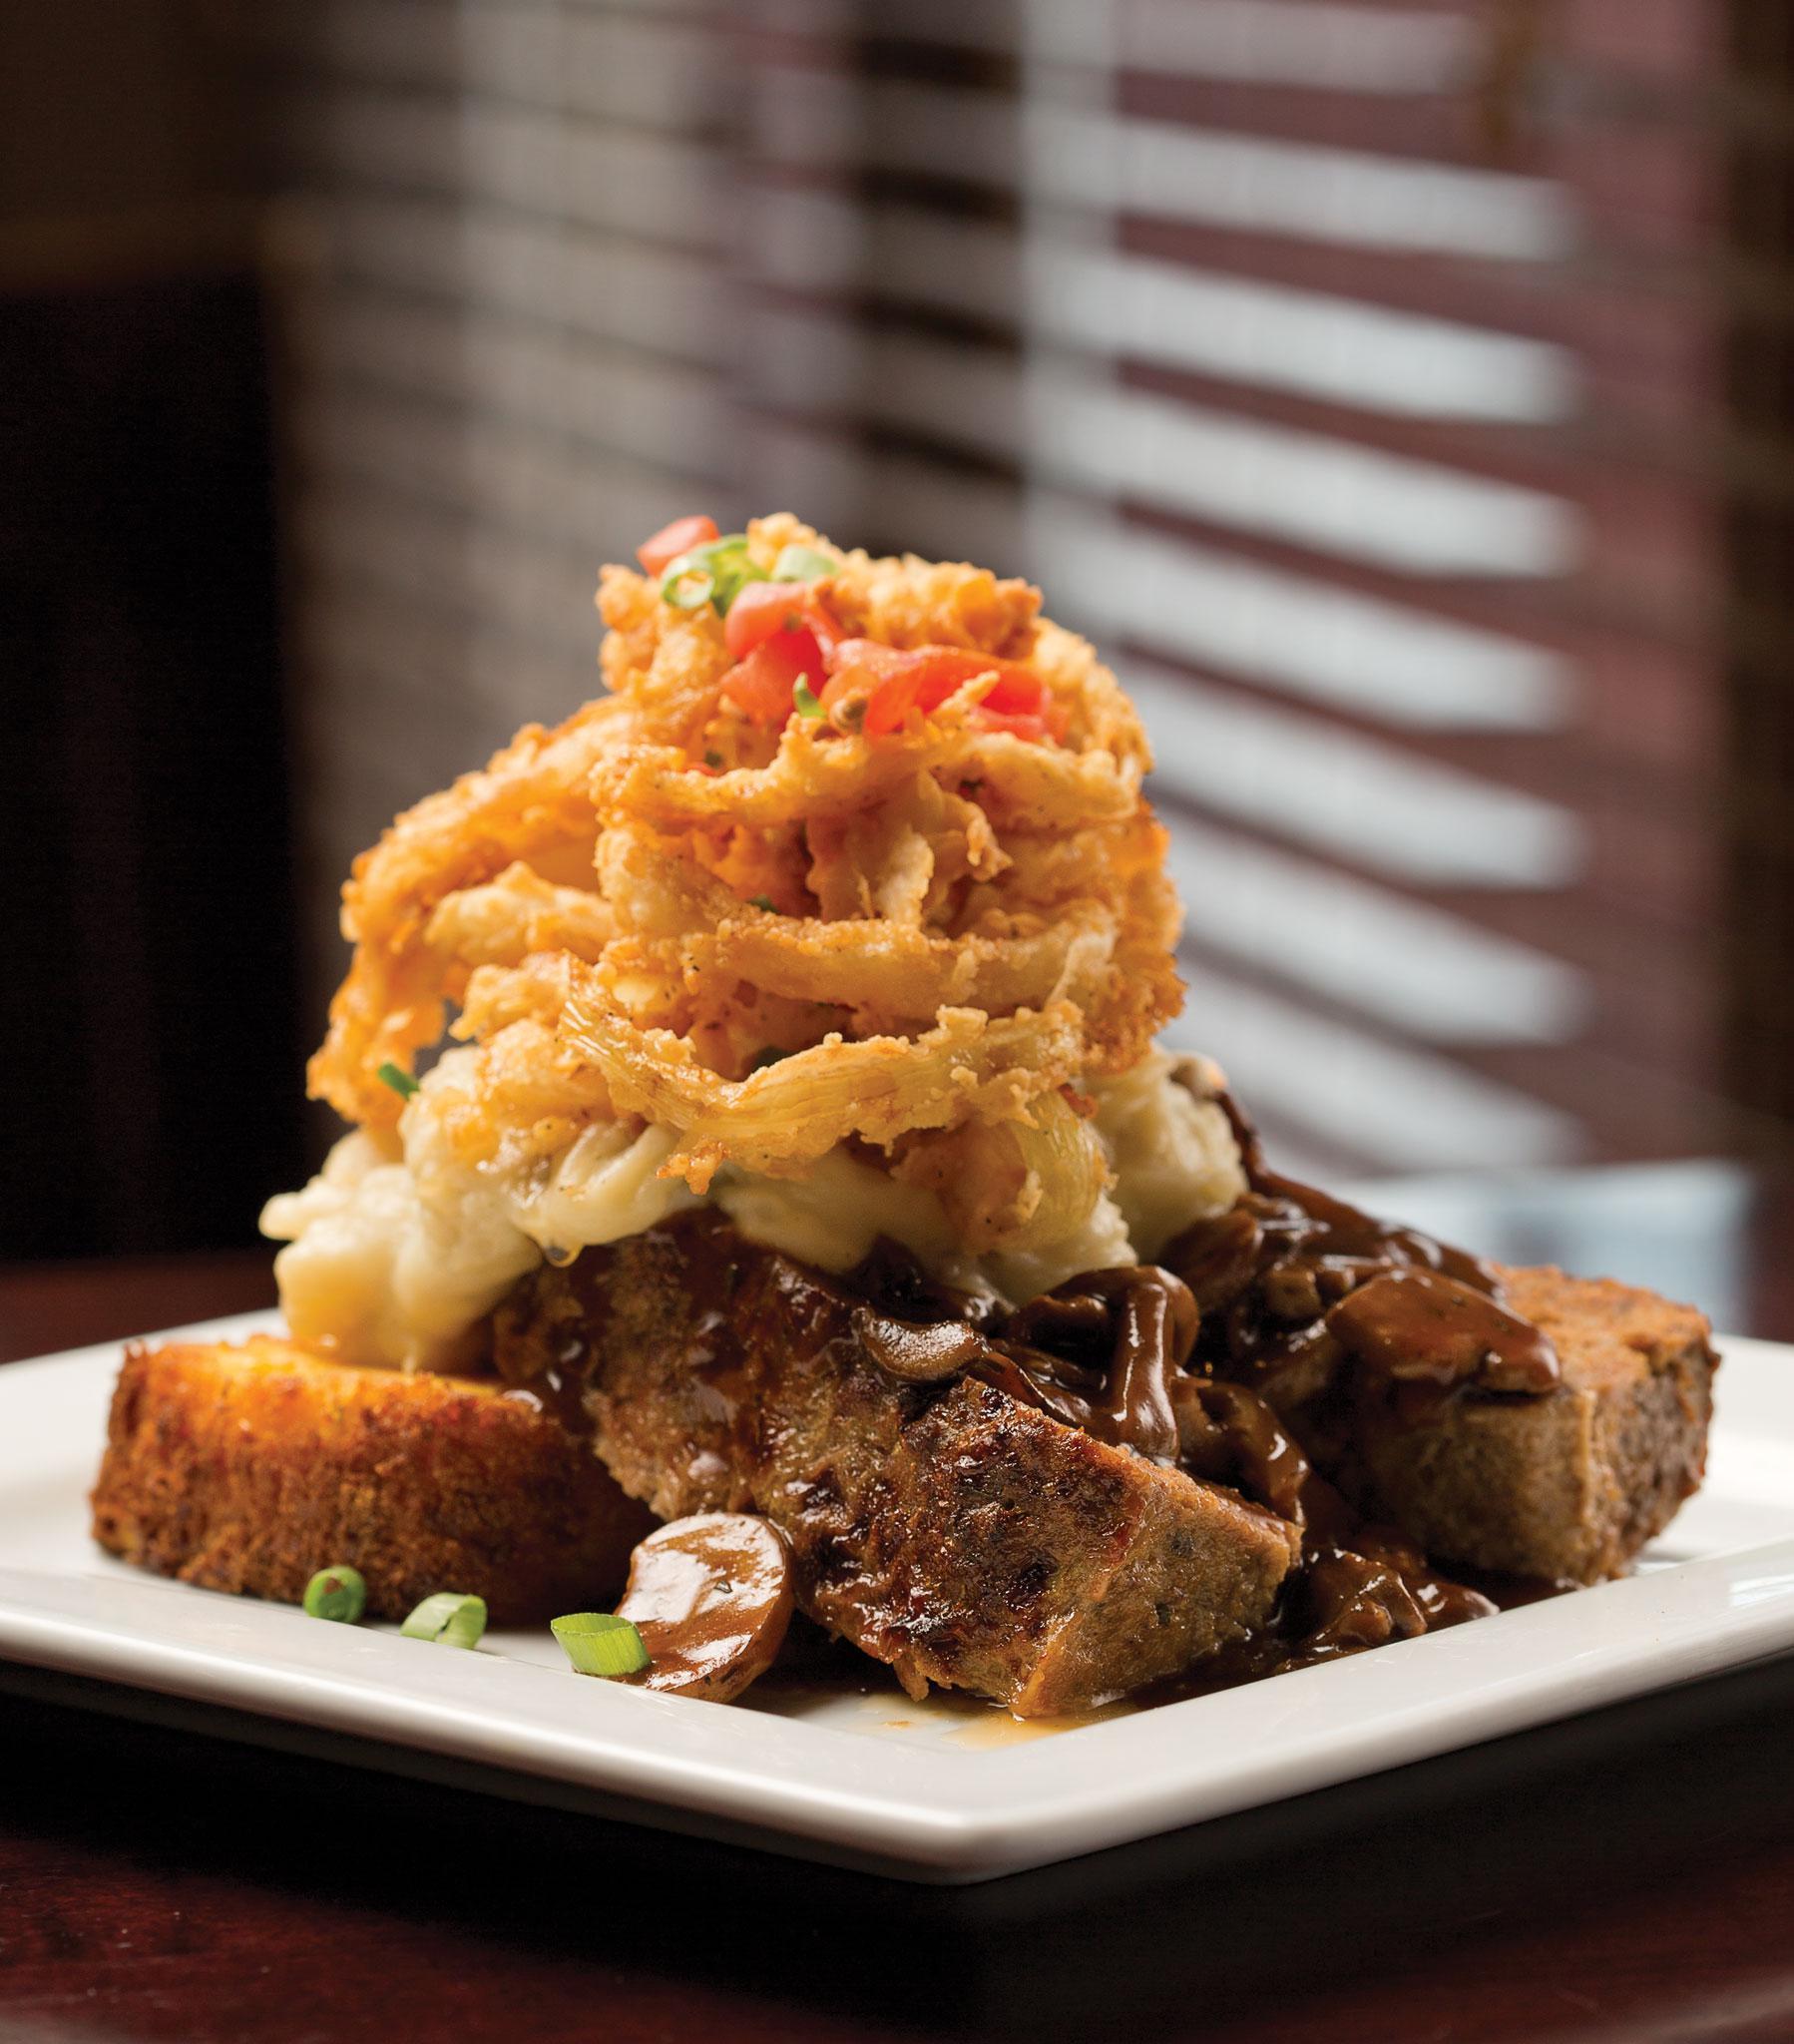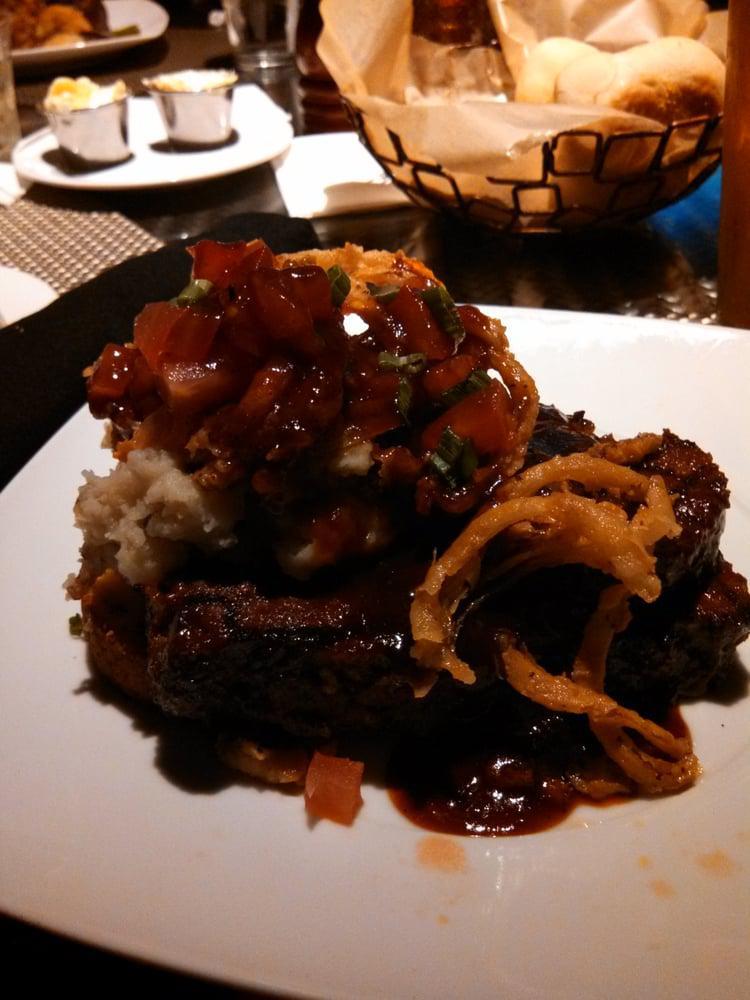The first image is the image on the left, the second image is the image on the right. Considering the images on both sides, is "The right dish is entirely layered, the left dish has a green vegetable." valid? Answer yes or no. No. The first image is the image on the left, the second image is the image on the right. For the images displayed, is the sentence "A serving of cooked green vegetables is on a plate next to some type of prepared meat." factually correct? Answer yes or no. No. 